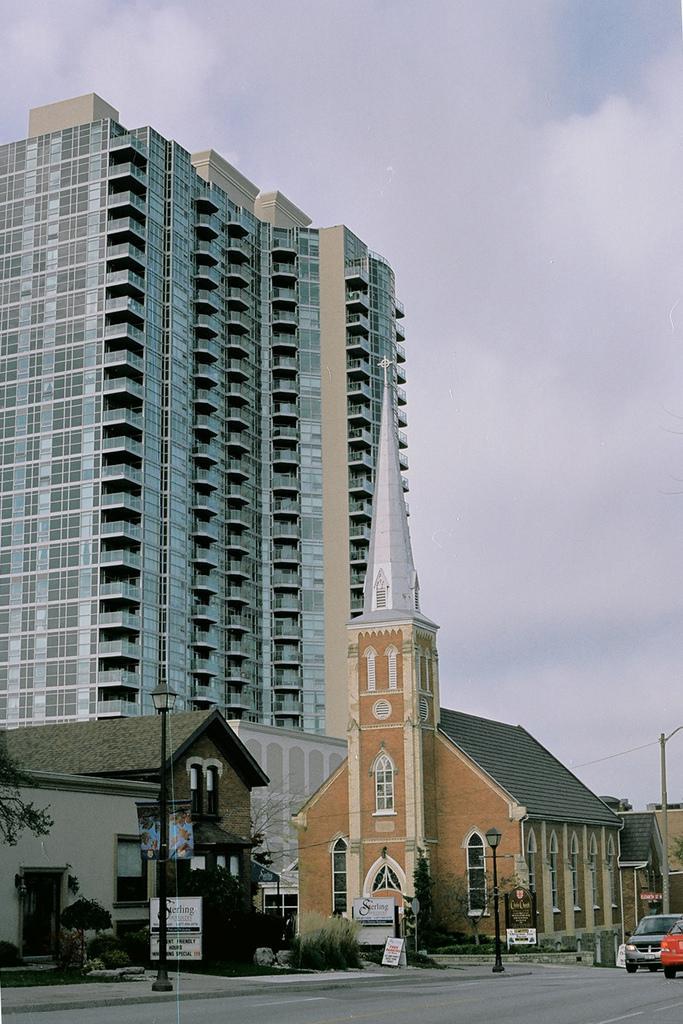In one or two sentences, can you explain what this image depicts? In this picture we can see the brown color church with roof top tiles in the front. Beside there is a road and some cars. In the background there is a big glass building. On the top there is a sky and clouds. 